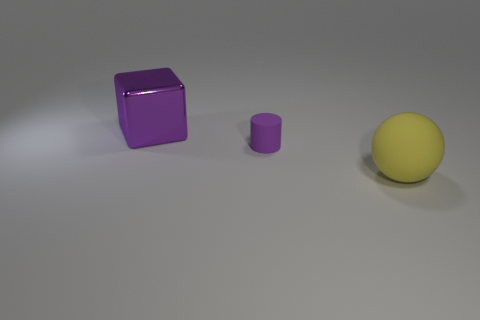Add 2 yellow metal things. How many objects exist? 5 Subtract all cubes. How many objects are left? 2 Add 3 tiny purple things. How many tiny purple things exist? 4 Subtract 0 blue blocks. How many objects are left? 3 Subtract all blue rubber cylinders. Subtract all metal cubes. How many objects are left? 2 Add 2 large yellow balls. How many large yellow balls are left? 3 